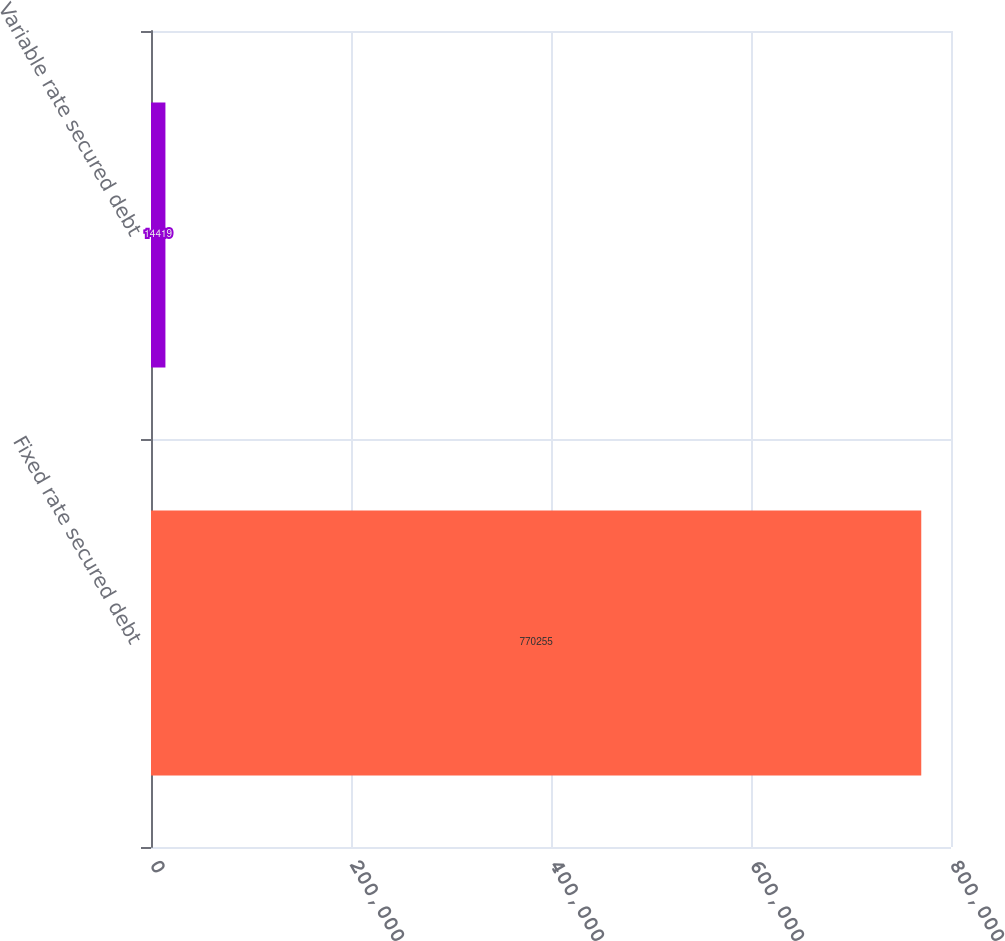Convert chart. <chart><loc_0><loc_0><loc_500><loc_500><bar_chart><fcel>Fixed rate secured debt<fcel>Variable rate secured debt<nl><fcel>770255<fcel>14419<nl></chart> 